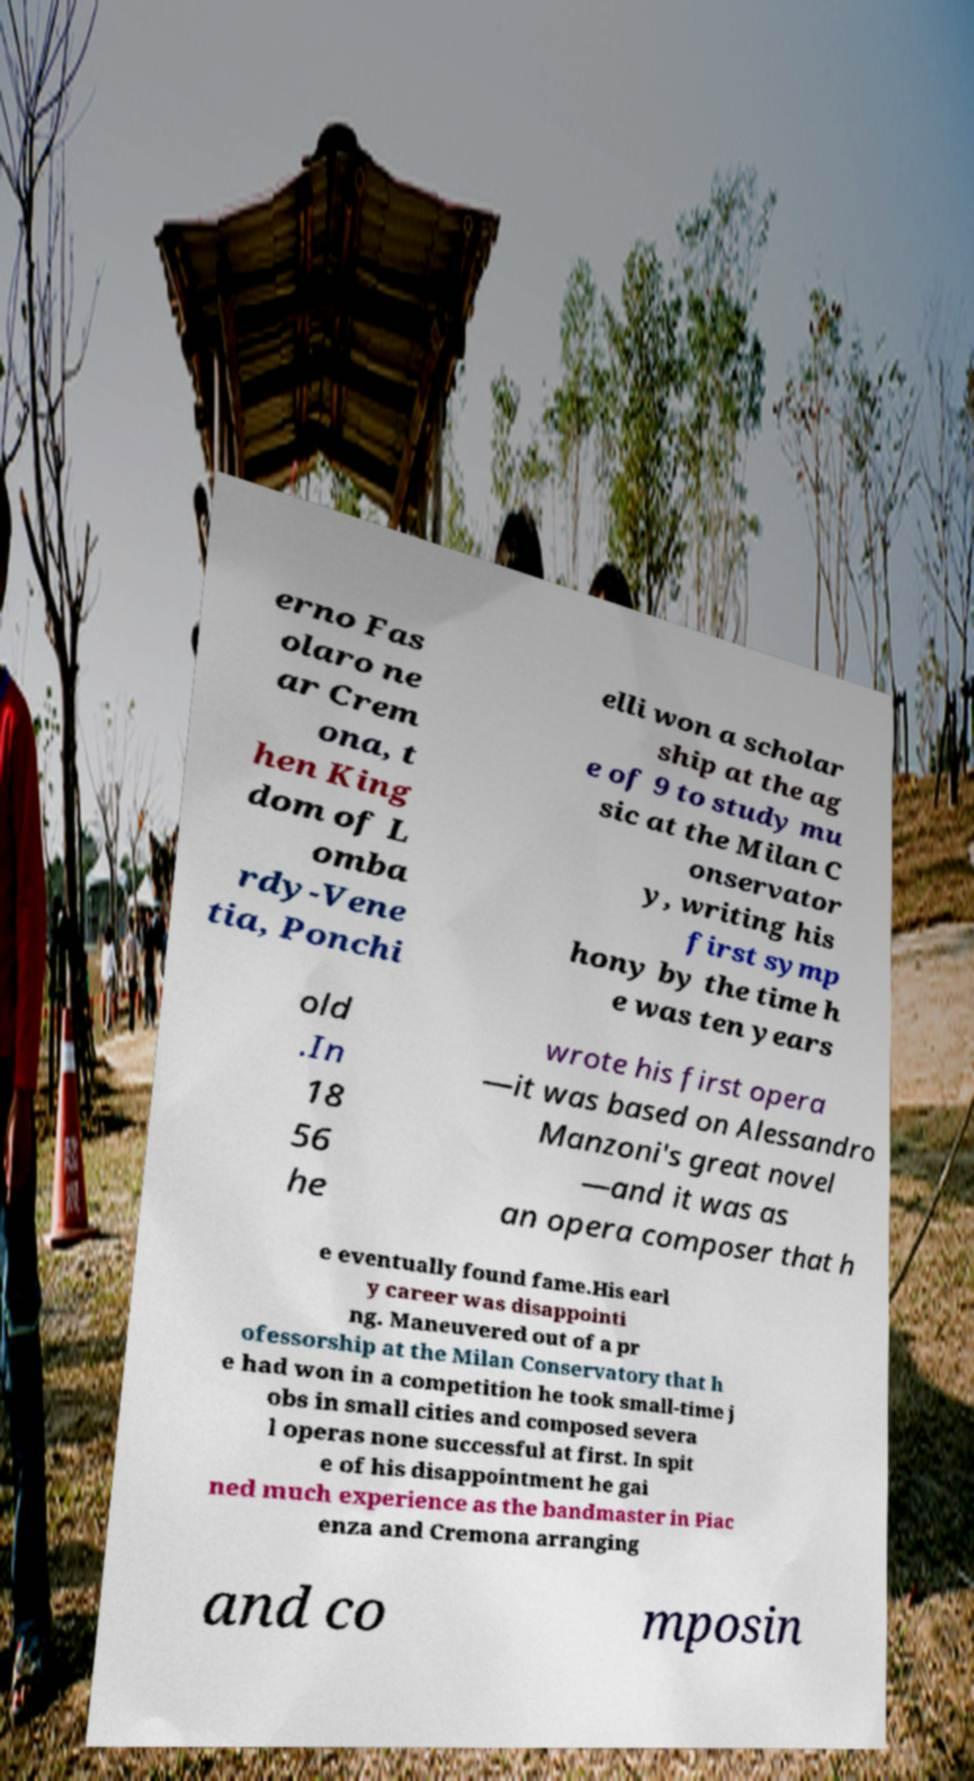Please identify and transcribe the text found in this image. erno Fas olaro ne ar Crem ona, t hen King dom of L omba rdy-Vene tia, Ponchi elli won a scholar ship at the ag e of 9 to study mu sic at the Milan C onservator y, writing his first symp hony by the time h e was ten years old .In 18 56 he wrote his first opera —it was based on Alessandro Manzoni's great novel —and it was as an opera composer that h e eventually found fame.His earl y career was disappointi ng. Maneuvered out of a pr ofessorship at the Milan Conservatory that h e had won in a competition he took small-time j obs in small cities and composed severa l operas none successful at first. In spit e of his disappointment he gai ned much experience as the bandmaster in Piac enza and Cremona arranging and co mposin 